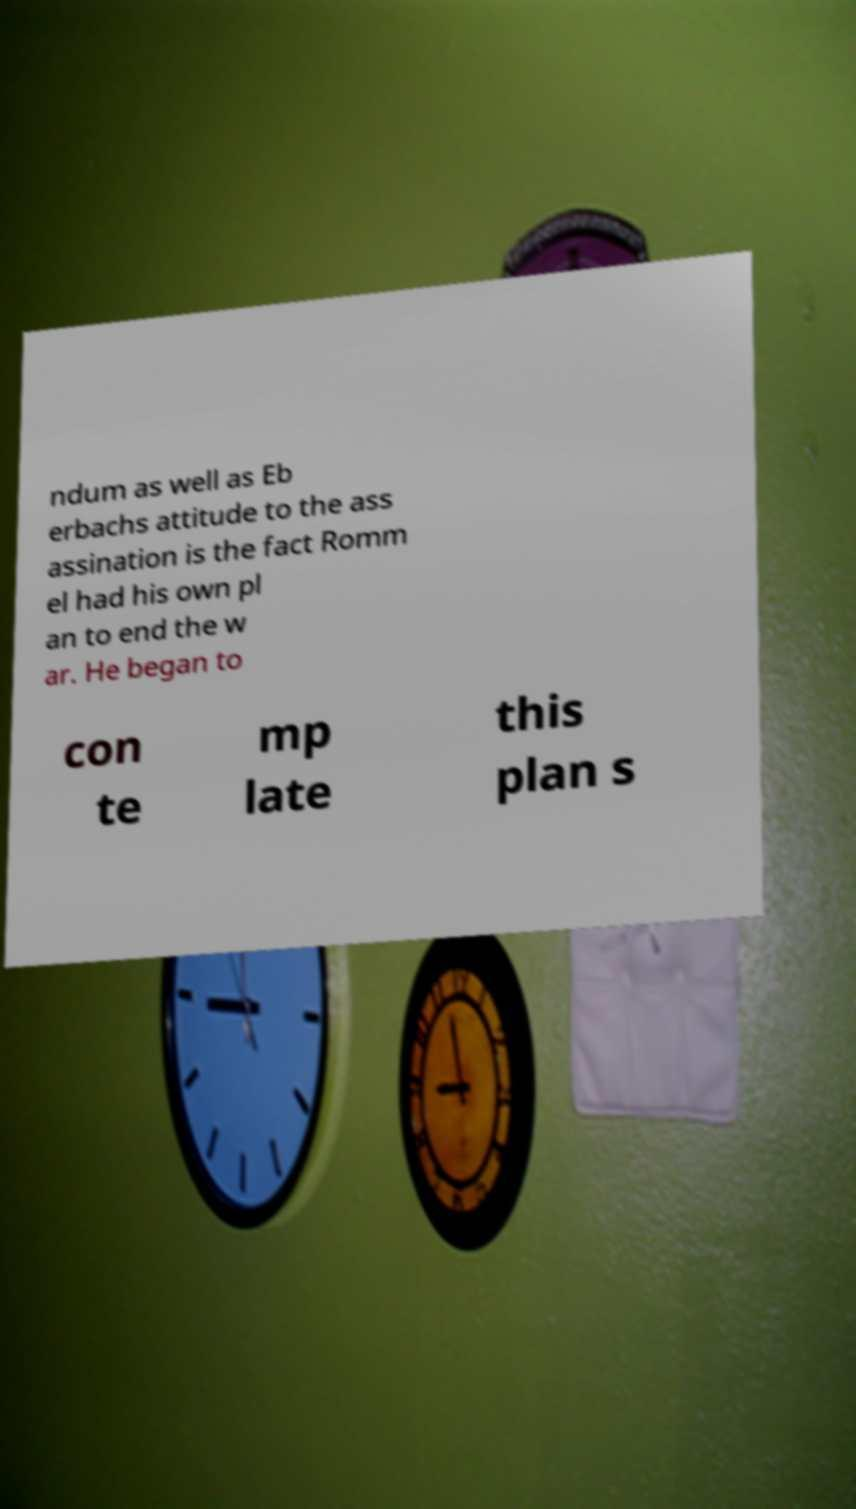I need the written content from this picture converted into text. Can you do that? ndum as well as Eb erbachs attitude to the ass assination is the fact Romm el had his own pl an to end the w ar. He began to con te mp late this plan s 